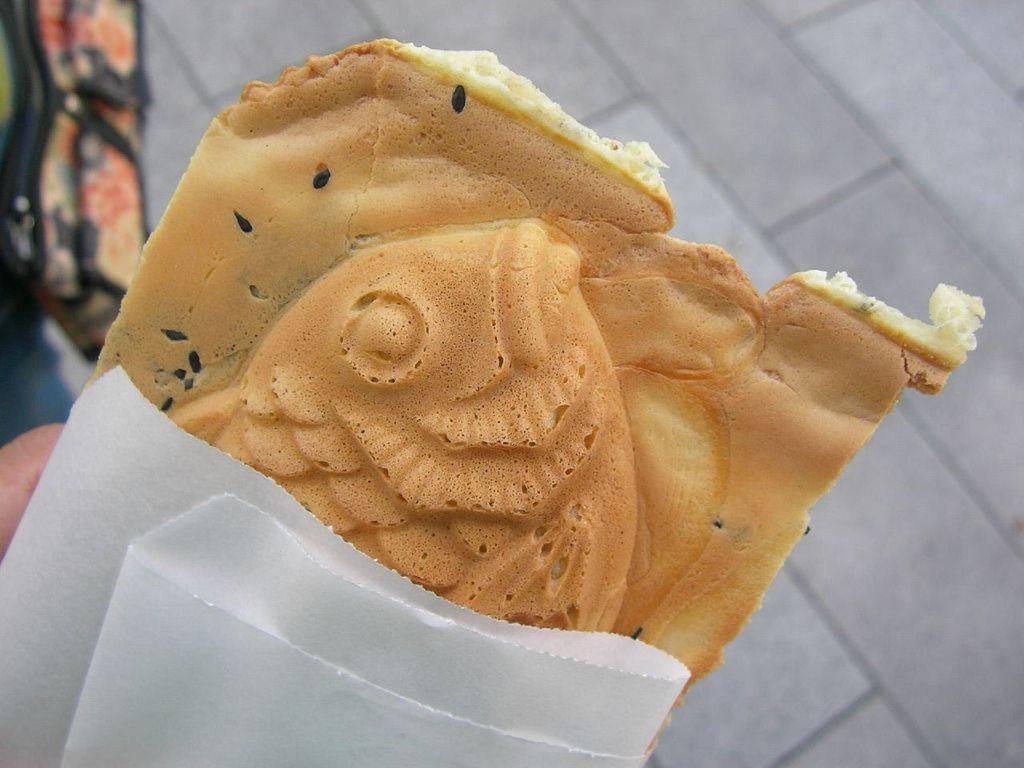Can you describe this image briefly? In the foreground of this picture, we can see the bread and a paper holding by a person. In the background, there is a bag and the floor. 